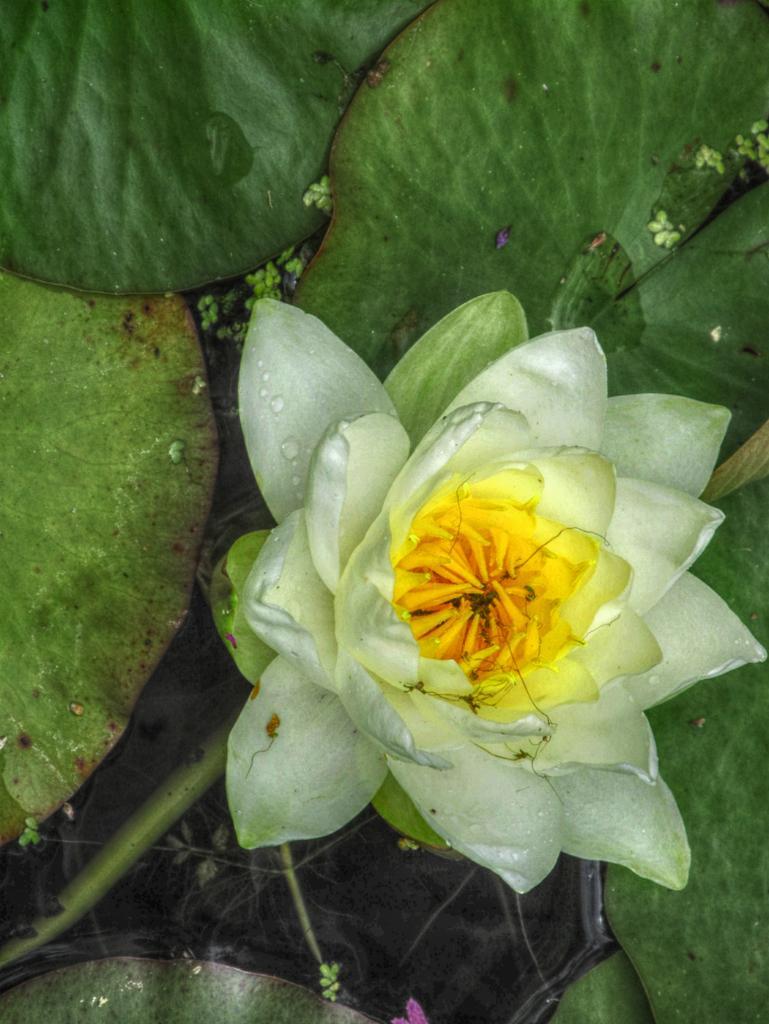Please provide a concise description of this image. In this picture we can see a flower and leaves. 